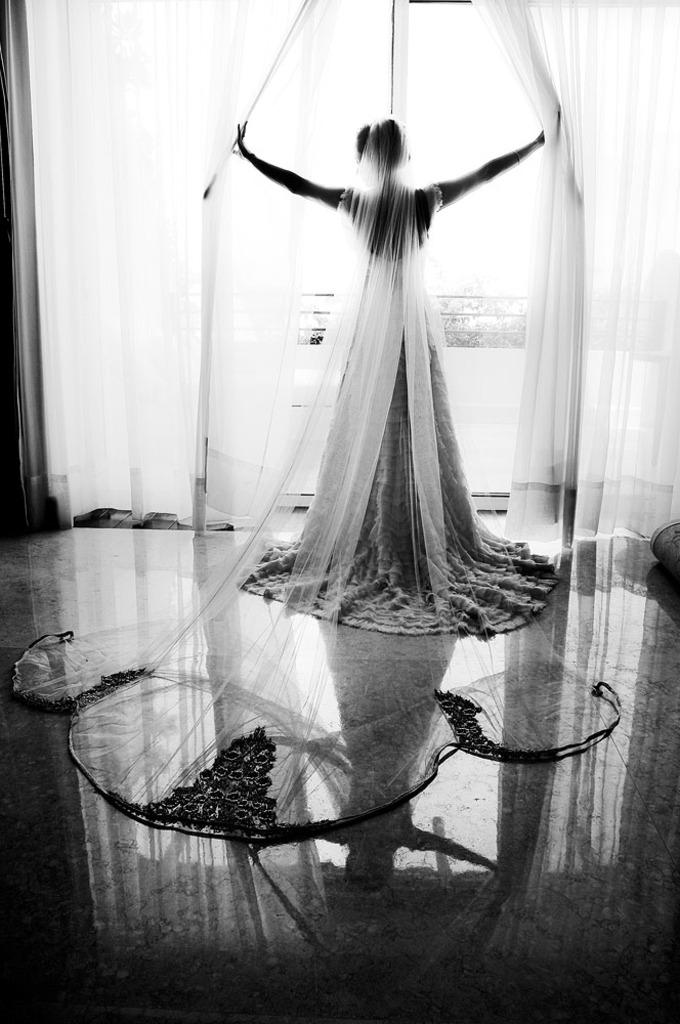What type of subject is present in the image? There is a human in the image. What type of window treatment can be seen in the image? There are curtains visible in the image. What can be inferred about the location of the image? The image appears to be an inner view of a room. What type of feeling does the sort offer to the human in the image? There is no mention of a sort or feeling in the image; it only shows a human and curtains in a room. 